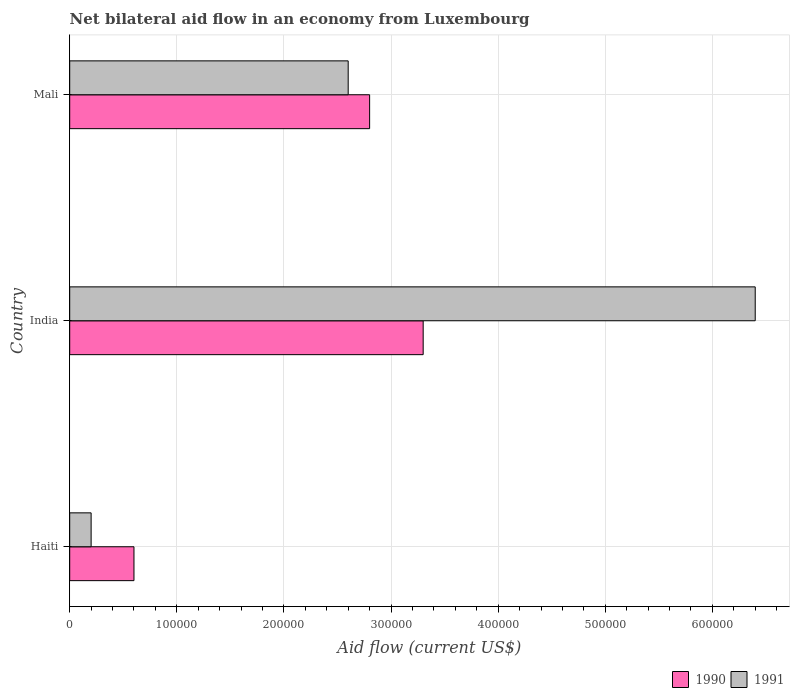How many bars are there on the 3rd tick from the top?
Make the answer very short. 2. How many bars are there on the 2nd tick from the bottom?
Your answer should be compact. 2. What is the label of the 1st group of bars from the top?
Your answer should be compact. Mali. In how many cases, is the number of bars for a given country not equal to the number of legend labels?
Your response must be concise. 0. What is the net bilateral aid flow in 1991 in India?
Offer a terse response. 6.40e+05. Across all countries, what is the maximum net bilateral aid flow in 1991?
Make the answer very short. 6.40e+05. Across all countries, what is the minimum net bilateral aid flow in 1991?
Give a very brief answer. 2.00e+04. In which country was the net bilateral aid flow in 1991 minimum?
Your answer should be very brief. Haiti. What is the total net bilateral aid flow in 1990 in the graph?
Give a very brief answer. 6.70e+05. What is the difference between the net bilateral aid flow in 1991 in Haiti and that in Mali?
Your response must be concise. -2.40e+05. What is the difference between the net bilateral aid flow in 1990 in Haiti and the net bilateral aid flow in 1991 in India?
Provide a short and direct response. -5.80e+05. What is the average net bilateral aid flow in 1990 per country?
Your answer should be very brief. 2.23e+05. What is the difference between the net bilateral aid flow in 1990 and net bilateral aid flow in 1991 in Haiti?
Ensure brevity in your answer.  4.00e+04. In how many countries, is the net bilateral aid flow in 1990 greater than 380000 US$?
Make the answer very short. 0. What is the ratio of the net bilateral aid flow in 1990 in Haiti to that in India?
Make the answer very short. 0.18. What is the difference between the highest and the second highest net bilateral aid flow in 1991?
Make the answer very short. 3.80e+05. What is the difference between the highest and the lowest net bilateral aid flow in 1990?
Your response must be concise. 2.70e+05. What does the 2nd bar from the top in India represents?
Your answer should be compact. 1990. What does the 2nd bar from the bottom in Mali represents?
Your answer should be compact. 1991. How many bars are there?
Provide a succinct answer. 6. Are the values on the major ticks of X-axis written in scientific E-notation?
Your answer should be very brief. No. Does the graph contain any zero values?
Offer a terse response. No. Does the graph contain grids?
Provide a short and direct response. Yes. How many legend labels are there?
Your answer should be very brief. 2. What is the title of the graph?
Offer a terse response. Net bilateral aid flow in an economy from Luxembourg. What is the Aid flow (current US$) in 1990 in Haiti?
Your response must be concise. 6.00e+04. What is the Aid flow (current US$) in 1991 in Haiti?
Your answer should be compact. 2.00e+04. What is the Aid flow (current US$) of 1991 in India?
Your response must be concise. 6.40e+05. What is the Aid flow (current US$) in 1990 in Mali?
Offer a terse response. 2.80e+05. Across all countries, what is the maximum Aid flow (current US$) of 1990?
Your answer should be compact. 3.30e+05. Across all countries, what is the maximum Aid flow (current US$) of 1991?
Your answer should be compact. 6.40e+05. Across all countries, what is the minimum Aid flow (current US$) of 1990?
Keep it short and to the point. 6.00e+04. What is the total Aid flow (current US$) in 1990 in the graph?
Make the answer very short. 6.70e+05. What is the total Aid flow (current US$) in 1991 in the graph?
Keep it short and to the point. 9.20e+05. What is the difference between the Aid flow (current US$) in 1991 in Haiti and that in India?
Your response must be concise. -6.20e+05. What is the difference between the Aid flow (current US$) in 1990 in Haiti and the Aid flow (current US$) in 1991 in India?
Keep it short and to the point. -5.80e+05. What is the difference between the Aid flow (current US$) in 1990 in Haiti and the Aid flow (current US$) in 1991 in Mali?
Keep it short and to the point. -2.00e+05. What is the difference between the Aid flow (current US$) in 1990 in India and the Aid flow (current US$) in 1991 in Mali?
Your answer should be very brief. 7.00e+04. What is the average Aid flow (current US$) in 1990 per country?
Ensure brevity in your answer.  2.23e+05. What is the average Aid flow (current US$) in 1991 per country?
Your answer should be very brief. 3.07e+05. What is the difference between the Aid flow (current US$) in 1990 and Aid flow (current US$) in 1991 in India?
Provide a short and direct response. -3.10e+05. What is the ratio of the Aid flow (current US$) in 1990 in Haiti to that in India?
Your answer should be compact. 0.18. What is the ratio of the Aid flow (current US$) in 1991 in Haiti to that in India?
Make the answer very short. 0.03. What is the ratio of the Aid flow (current US$) of 1990 in Haiti to that in Mali?
Offer a terse response. 0.21. What is the ratio of the Aid flow (current US$) in 1991 in Haiti to that in Mali?
Provide a short and direct response. 0.08. What is the ratio of the Aid flow (current US$) in 1990 in India to that in Mali?
Keep it short and to the point. 1.18. What is the ratio of the Aid flow (current US$) in 1991 in India to that in Mali?
Your answer should be very brief. 2.46. What is the difference between the highest and the second highest Aid flow (current US$) in 1990?
Give a very brief answer. 5.00e+04. What is the difference between the highest and the second highest Aid flow (current US$) in 1991?
Your answer should be compact. 3.80e+05. What is the difference between the highest and the lowest Aid flow (current US$) of 1991?
Offer a terse response. 6.20e+05. 